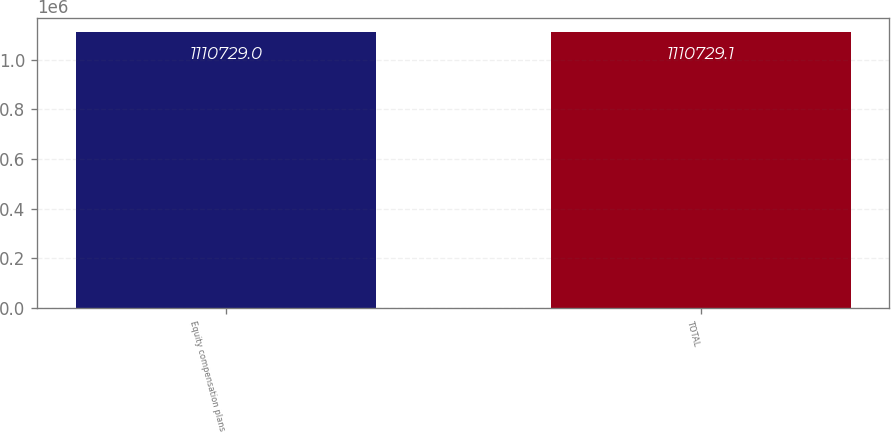Convert chart to OTSL. <chart><loc_0><loc_0><loc_500><loc_500><bar_chart><fcel>Equity compensation plans<fcel>TOTAL<nl><fcel>1.11073e+06<fcel>1.11073e+06<nl></chart> 